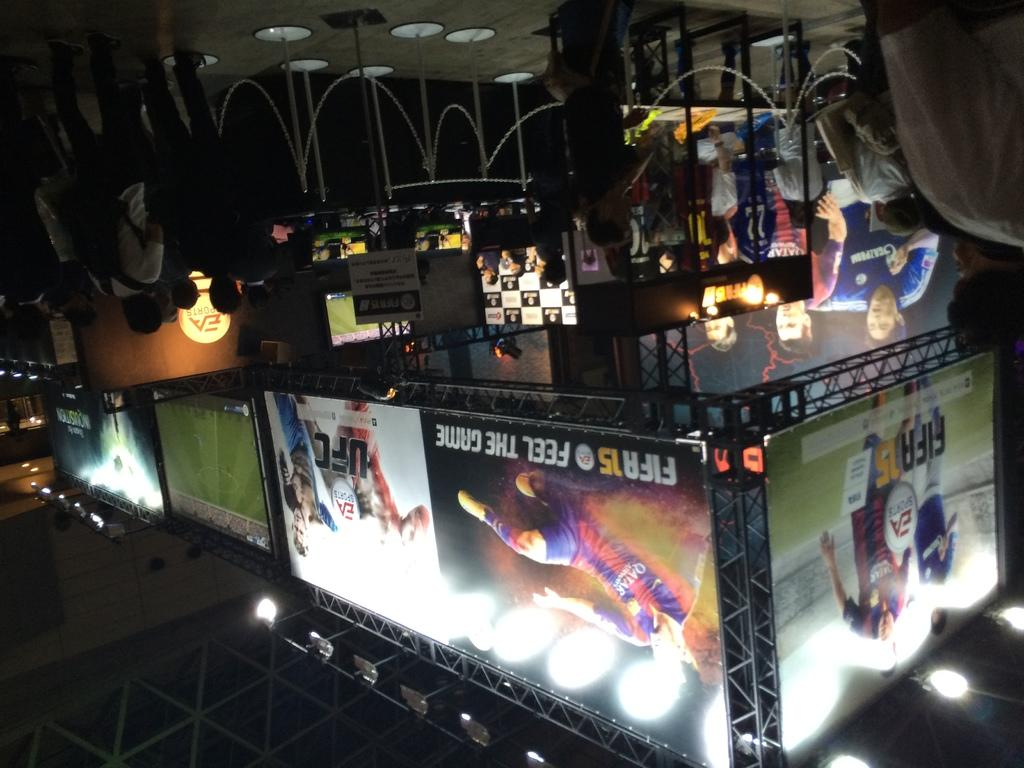How many people are in the image? There is a group of people in the image, but the exact number is not specified. What is the position of the people in the image? The people are standing on the floor in the image. What type of signage is present in the image? There are hoardings and banners in the image. What other elements can be seen in the image? There are lights in the image. How many frogs are sitting on the drum in the image? There are no frogs or drums present in the image. 